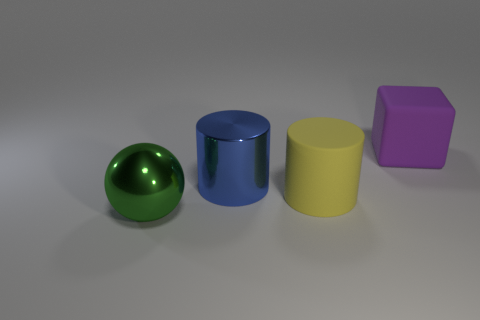Add 3 big green things. How many objects exist? 7 Subtract all blocks. How many objects are left? 3 Add 3 blue shiny cylinders. How many blue shiny cylinders are left? 4 Add 4 large green metal things. How many large green metal things exist? 5 Subtract 0 brown blocks. How many objects are left? 4 Subtract all big blue cylinders. Subtract all big metal balls. How many objects are left? 2 